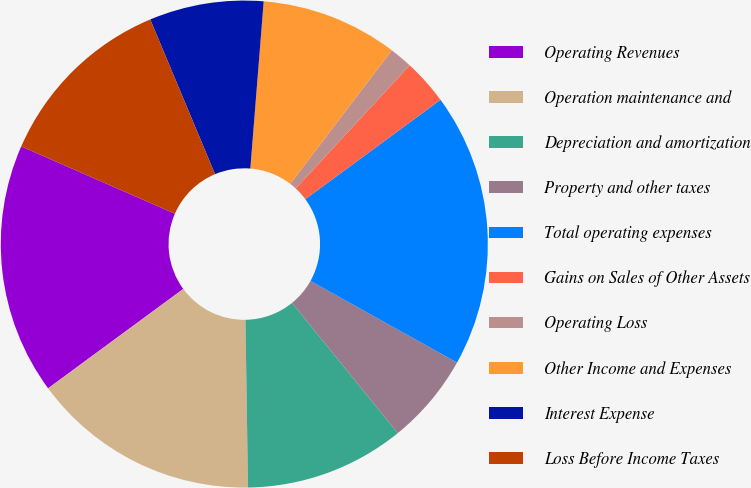<chart> <loc_0><loc_0><loc_500><loc_500><pie_chart><fcel>Operating Revenues<fcel>Operation maintenance and<fcel>Depreciation and amortization<fcel>Property and other taxes<fcel>Total operating expenses<fcel>Gains on Sales of Other Assets<fcel>Operating Loss<fcel>Other Income and Expenses<fcel>Interest Expense<fcel>Loss Before Income Taxes<nl><fcel>16.66%<fcel>15.15%<fcel>10.61%<fcel>6.06%<fcel>18.18%<fcel>3.03%<fcel>1.52%<fcel>9.09%<fcel>7.58%<fcel>12.12%<nl></chart> 